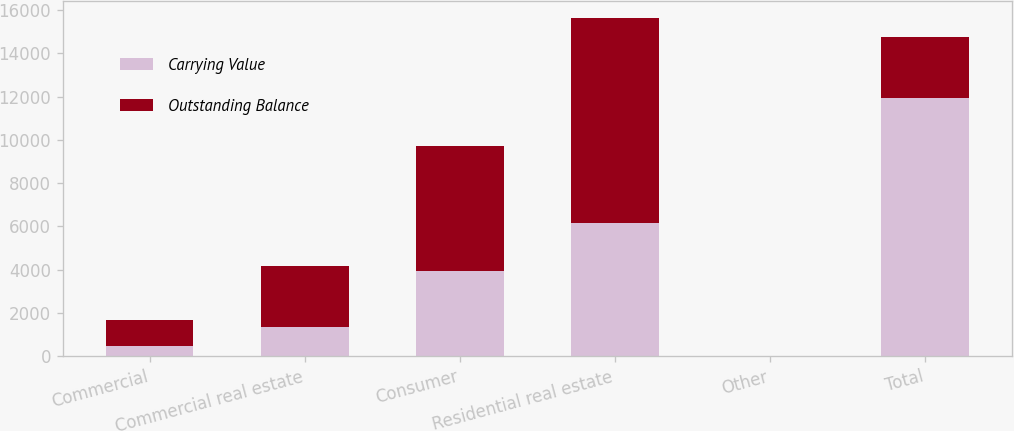Convert chart to OTSL. <chart><loc_0><loc_0><loc_500><loc_500><stacked_bar_chart><ecel><fcel>Commercial<fcel>Commercial real estate<fcel>Consumer<fcel>Residential real estate<fcel>Other<fcel>Total<nl><fcel>Carrying Value<fcel>493<fcel>1340<fcel>3924<fcel>6154<fcel>10<fcel>11921<nl><fcel>Outstanding Balance<fcel>1180<fcel>2831<fcel>5785<fcel>9482<fcel>14<fcel>2831<nl></chart> 